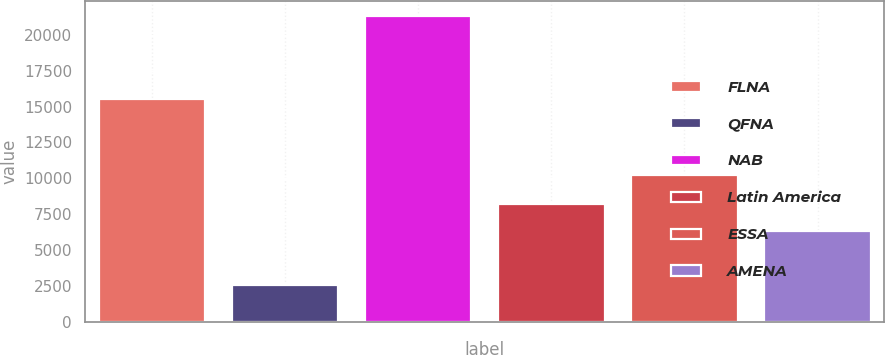<chart> <loc_0><loc_0><loc_500><loc_500><bar_chart><fcel>FLNA<fcel>QFNA<fcel>NAB<fcel>Latin America<fcel>ESSA<fcel>AMENA<nl><fcel>15549<fcel>2564<fcel>21312<fcel>8212.8<fcel>10216<fcel>6338<nl></chart> 